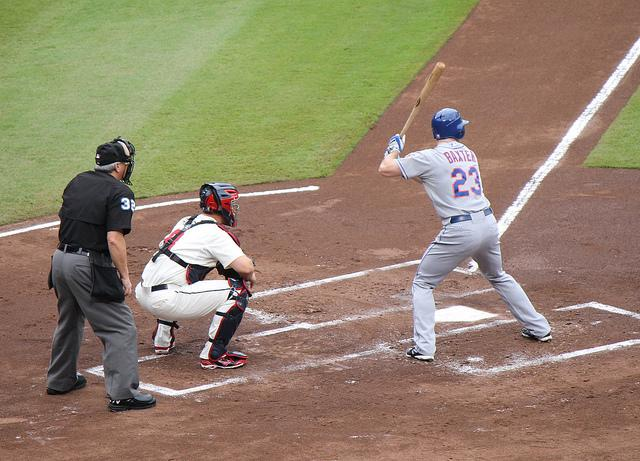Who is the away team? Please explain your reasoning. yankees. The yankees are the away team as indicated by the uniforms. 